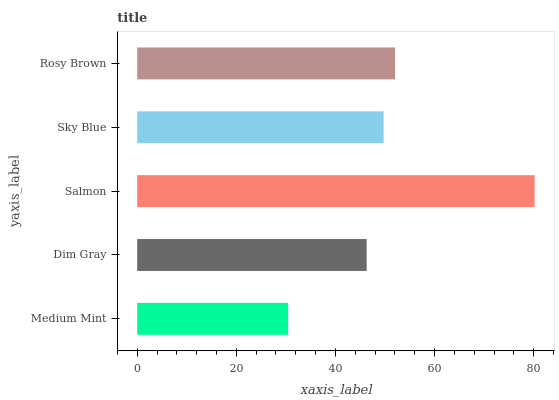Is Medium Mint the minimum?
Answer yes or no. Yes. Is Salmon the maximum?
Answer yes or no. Yes. Is Dim Gray the minimum?
Answer yes or no. No. Is Dim Gray the maximum?
Answer yes or no. No. Is Dim Gray greater than Medium Mint?
Answer yes or no. Yes. Is Medium Mint less than Dim Gray?
Answer yes or no. Yes. Is Medium Mint greater than Dim Gray?
Answer yes or no. No. Is Dim Gray less than Medium Mint?
Answer yes or no. No. Is Sky Blue the high median?
Answer yes or no. Yes. Is Sky Blue the low median?
Answer yes or no. Yes. Is Medium Mint the high median?
Answer yes or no. No. Is Salmon the low median?
Answer yes or no. No. 